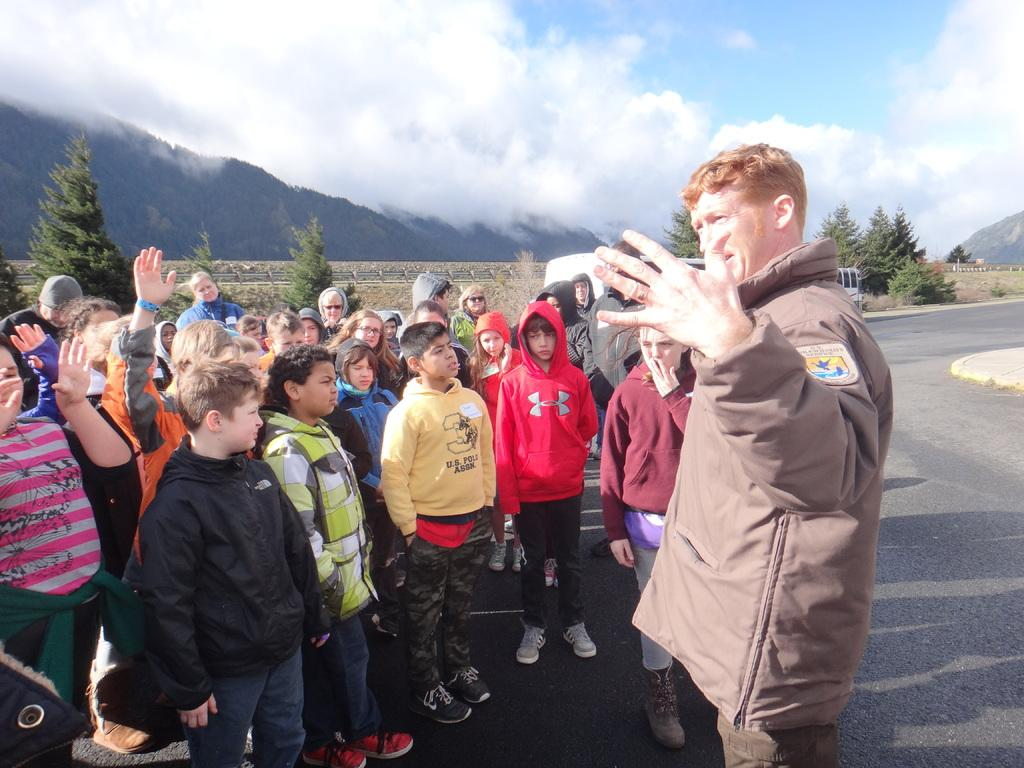What can be seen in the foreground of the image? There are people standing in the foreground of the image. What type of natural elements are visible in the background of the image? There are trees and mountains in the background of the image. What part of the sky is visible in the image? The sky is visible in the background of the image. How many women are seen walking on the trail in the image? There is no trail or women present in the image; it features people standing in the foreground and natural elements in the background. 